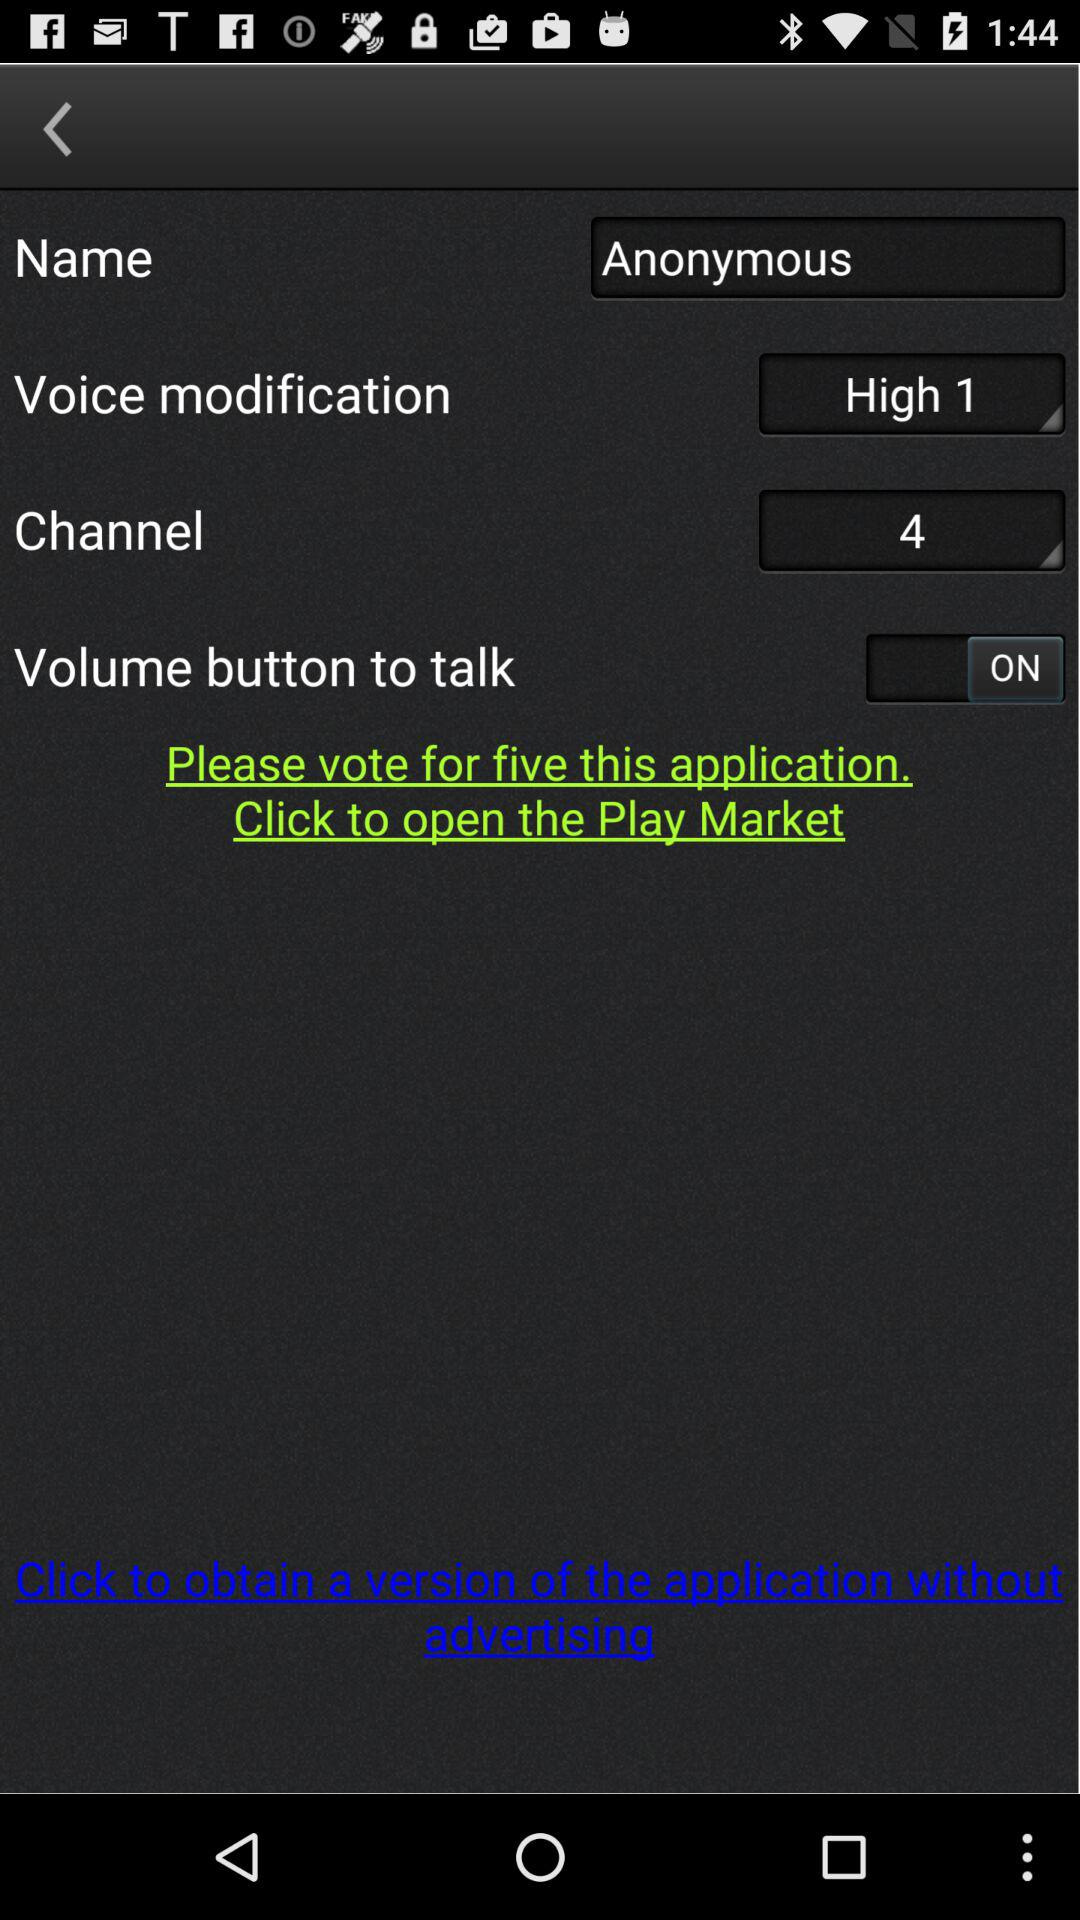What is the status of the voice modification? The status is "High 1". 